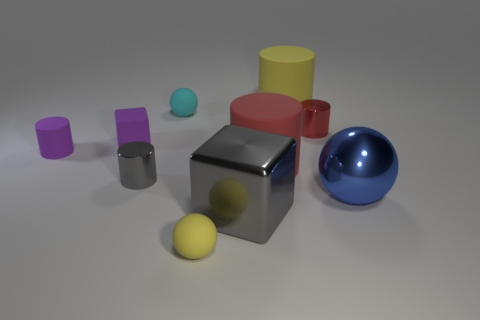Subtract all tiny rubber balls. How many balls are left? 1 Subtract all green blocks. How many red cylinders are left? 2 Subtract 4 cylinders. How many cylinders are left? 1 Subtract all red cylinders. How many cylinders are left? 3 Subtract all blocks. How many objects are left? 8 Subtract all yellow balls. Subtract all red cylinders. How many balls are left? 2 Subtract all large green cylinders. Subtract all tiny red metal things. How many objects are left? 9 Add 8 blue metal objects. How many blue metal objects are left? 9 Add 3 large yellow cylinders. How many large yellow cylinders exist? 4 Subtract 1 gray cylinders. How many objects are left? 9 